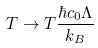Convert formula to latex. <formula><loc_0><loc_0><loc_500><loc_500>T \rightarrow T \frac { \hbar { c } _ { 0 } \Lambda } { k _ { B } }</formula> 